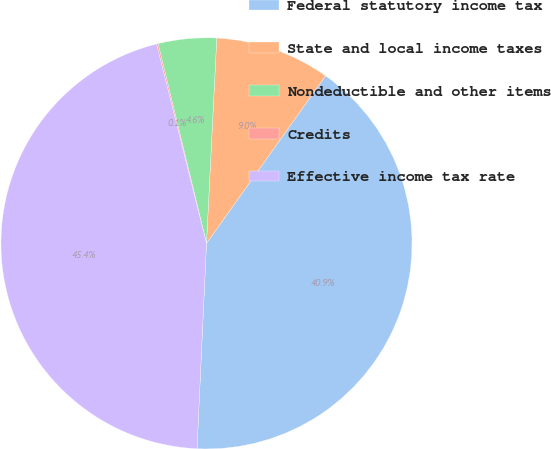Convert chart. <chart><loc_0><loc_0><loc_500><loc_500><pie_chart><fcel>Federal statutory income tax<fcel>State and local income taxes<fcel>Nondeductible and other items<fcel>Credits<fcel>Effective income tax rate<nl><fcel>40.9%<fcel>9.04%<fcel>4.58%<fcel>0.12%<fcel>45.36%<nl></chart> 